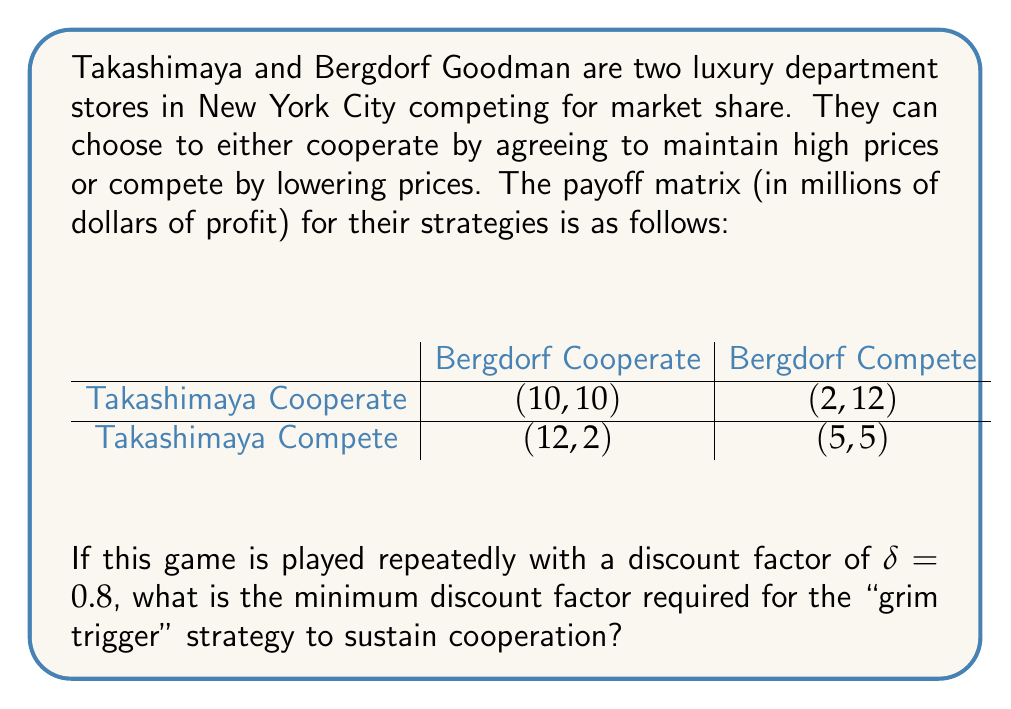Can you solve this math problem? To solve this problem, we need to use the concept of the grim trigger strategy in repeated games. The grim trigger strategy involves cooperating initially and continuing to cooperate as long as the other player cooperates, but switching to perpetual competition if the other player ever defects.

For the grim trigger strategy to be effective, the long-term benefit of cooperation must outweigh the short-term gain from defecting. We can calculate this using the following steps:

1. Calculate the payoff from perpetual cooperation:
   $V_c = 10 + 10\delta + 10\delta^2 + ... = \frac{10}{1-\delta}$

2. Calculate the payoff from defecting once and then facing perpetual competition:
   $V_d = 12 + 5\delta + 5\delta^2 + ... = 12 + \frac{5\delta}{1-\delta}$

3. For the grim trigger strategy to work, we need $V_c \geq V_d$:

   $$\frac{10}{1-\delta} \geq 12 + \frac{5\delta}{1-\delta}$$

4. Solve this inequality for $\delta$:

   $$10 \geq 12(1-\delta) + 5\delta$$
   $$10 \geq 12 - 12\delta + 5\delta$$
   $$10 \geq 12 - 7\delta$$
   $$7\delta \geq 2$$
   $$\delta \geq \frac{2}{7} \approx 0.2857$$

5. Therefore, the minimum discount factor required is $\frac{2}{7}$.

Since the given discount factor (0.8) is greater than this minimum, the grim trigger strategy can sustain cooperation in this scenario.
Answer: The minimum discount factor required for the grim trigger strategy to sustain cooperation is $\frac{2}{7} \approx 0.2857$. 